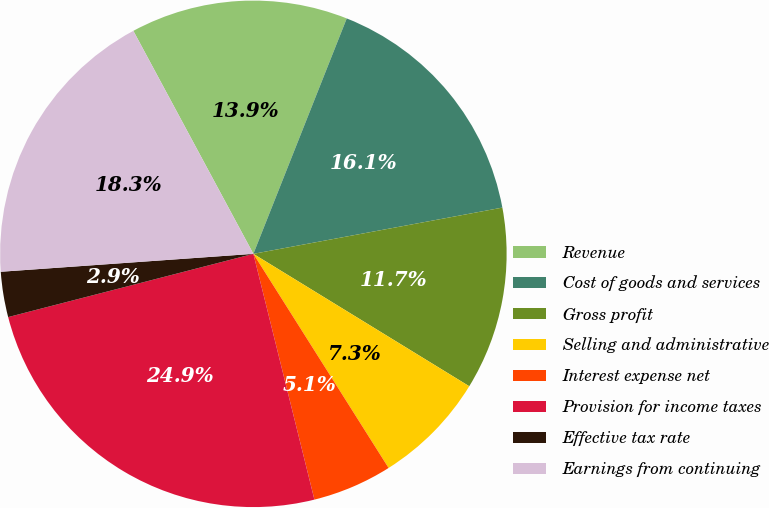Convert chart to OTSL. <chart><loc_0><loc_0><loc_500><loc_500><pie_chart><fcel>Revenue<fcel>Cost of goods and services<fcel>Gross profit<fcel>Selling and administrative<fcel>Interest expense net<fcel>Provision for income taxes<fcel>Effective tax rate<fcel>Earnings from continuing<nl><fcel>13.87%<fcel>16.07%<fcel>11.68%<fcel>7.28%<fcel>5.09%<fcel>24.86%<fcel>2.89%<fcel>18.27%<nl></chart> 